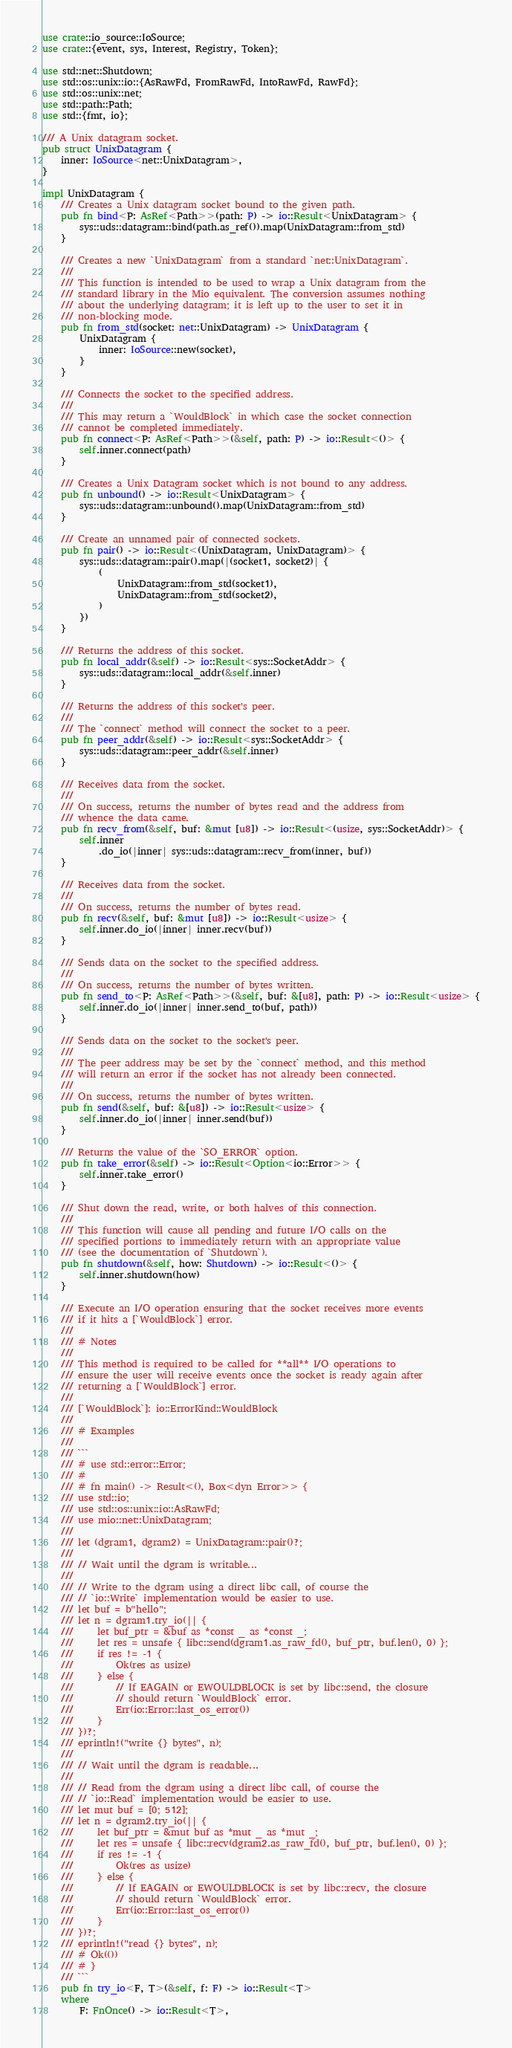<code> <loc_0><loc_0><loc_500><loc_500><_Rust_>use crate::io_source::IoSource;
use crate::{event, sys, Interest, Registry, Token};

use std::net::Shutdown;
use std::os::unix::io::{AsRawFd, FromRawFd, IntoRawFd, RawFd};
use std::os::unix::net;
use std::path::Path;
use std::{fmt, io};

/// A Unix datagram socket.
pub struct UnixDatagram {
    inner: IoSource<net::UnixDatagram>,
}

impl UnixDatagram {
    /// Creates a Unix datagram socket bound to the given path.
    pub fn bind<P: AsRef<Path>>(path: P) -> io::Result<UnixDatagram> {
        sys::uds::datagram::bind(path.as_ref()).map(UnixDatagram::from_std)
    }

    /// Creates a new `UnixDatagram` from a standard `net::UnixDatagram`.
    ///
    /// This function is intended to be used to wrap a Unix datagram from the
    /// standard library in the Mio equivalent. The conversion assumes nothing
    /// about the underlying datagram; it is left up to the user to set it in
    /// non-blocking mode.
    pub fn from_std(socket: net::UnixDatagram) -> UnixDatagram {
        UnixDatagram {
            inner: IoSource::new(socket),
        }
    }

    /// Connects the socket to the specified address.
    ///
    /// This may return a `WouldBlock` in which case the socket connection
    /// cannot be completed immediately.
    pub fn connect<P: AsRef<Path>>(&self, path: P) -> io::Result<()> {
        self.inner.connect(path)
    }

    /// Creates a Unix Datagram socket which is not bound to any address.
    pub fn unbound() -> io::Result<UnixDatagram> {
        sys::uds::datagram::unbound().map(UnixDatagram::from_std)
    }

    /// Create an unnamed pair of connected sockets.
    pub fn pair() -> io::Result<(UnixDatagram, UnixDatagram)> {
        sys::uds::datagram::pair().map(|(socket1, socket2)| {
            (
                UnixDatagram::from_std(socket1),
                UnixDatagram::from_std(socket2),
            )
        })
    }

    /// Returns the address of this socket.
    pub fn local_addr(&self) -> io::Result<sys::SocketAddr> {
        sys::uds::datagram::local_addr(&self.inner)
    }

    /// Returns the address of this socket's peer.
    ///
    /// The `connect` method will connect the socket to a peer.
    pub fn peer_addr(&self) -> io::Result<sys::SocketAddr> {
        sys::uds::datagram::peer_addr(&self.inner)
    }

    /// Receives data from the socket.
    ///
    /// On success, returns the number of bytes read and the address from
    /// whence the data came.
    pub fn recv_from(&self, buf: &mut [u8]) -> io::Result<(usize, sys::SocketAddr)> {
        self.inner
            .do_io(|inner| sys::uds::datagram::recv_from(inner, buf))
    }

    /// Receives data from the socket.
    ///
    /// On success, returns the number of bytes read.
    pub fn recv(&self, buf: &mut [u8]) -> io::Result<usize> {
        self.inner.do_io(|inner| inner.recv(buf))
    }

    /// Sends data on the socket to the specified address.
    ///
    /// On success, returns the number of bytes written.
    pub fn send_to<P: AsRef<Path>>(&self, buf: &[u8], path: P) -> io::Result<usize> {
        self.inner.do_io(|inner| inner.send_to(buf, path))
    }

    /// Sends data on the socket to the socket's peer.
    ///
    /// The peer address may be set by the `connect` method, and this method
    /// will return an error if the socket has not already been connected.
    ///
    /// On success, returns the number of bytes written.
    pub fn send(&self, buf: &[u8]) -> io::Result<usize> {
        self.inner.do_io(|inner| inner.send(buf))
    }

    /// Returns the value of the `SO_ERROR` option.
    pub fn take_error(&self) -> io::Result<Option<io::Error>> {
        self.inner.take_error()
    }

    /// Shut down the read, write, or both halves of this connection.
    ///
    /// This function will cause all pending and future I/O calls on the
    /// specified portions to immediately return with an appropriate value
    /// (see the documentation of `Shutdown`).
    pub fn shutdown(&self, how: Shutdown) -> io::Result<()> {
        self.inner.shutdown(how)
    }

    /// Execute an I/O operation ensuring that the socket receives more events
    /// if it hits a [`WouldBlock`] error.
    ///
    /// # Notes
    ///
    /// This method is required to be called for **all** I/O operations to
    /// ensure the user will receive events once the socket is ready again after
    /// returning a [`WouldBlock`] error.
    ///
    /// [`WouldBlock`]: io::ErrorKind::WouldBlock
    ///
    /// # Examples
    ///
    /// ```
    /// # use std::error::Error;
    /// #
    /// # fn main() -> Result<(), Box<dyn Error>> {
    /// use std::io;
    /// use std::os::unix::io::AsRawFd;
    /// use mio::net::UnixDatagram;
    ///
    /// let (dgram1, dgram2) = UnixDatagram::pair()?;
    ///
    /// // Wait until the dgram is writable...
    ///
    /// // Write to the dgram using a direct libc call, of course the
    /// // `io::Write` implementation would be easier to use.
    /// let buf = b"hello";
    /// let n = dgram1.try_io(|| {
    ///     let buf_ptr = &buf as *const _ as *const _;
    ///     let res = unsafe { libc::send(dgram1.as_raw_fd(), buf_ptr, buf.len(), 0) };
    ///     if res != -1 {
    ///         Ok(res as usize)
    ///     } else {
    ///         // If EAGAIN or EWOULDBLOCK is set by libc::send, the closure
    ///         // should return `WouldBlock` error.
    ///         Err(io::Error::last_os_error())
    ///     }
    /// })?;
    /// eprintln!("write {} bytes", n);
    ///
    /// // Wait until the dgram is readable...
    ///
    /// // Read from the dgram using a direct libc call, of course the
    /// // `io::Read` implementation would be easier to use.
    /// let mut buf = [0; 512];
    /// let n = dgram2.try_io(|| {
    ///     let buf_ptr = &mut buf as *mut _ as *mut _;
    ///     let res = unsafe { libc::recv(dgram2.as_raw_fd(), buf_ptr, buf.len(), 0) };
    ///     if res != -1 {
    ///         Ok(res as usize)
    ///     } else {
    ///         // If EAGAIN or EWOULDBLOCK is set by libc::recv, the closure
    ///         // should return `WouldBlock` error.
    ///         Err(io::Error::last_os_error())
    ///     }
    /// })?;
    /// eprintln!("read {} bytes", n);
    /// # Ok(())
    /// # }
    /// ```
    pub fn try_io<F, T>(&self, f: F) -> io::Result<T>
    where
        F: FnOnce() -> io::Result<T>,</code> 